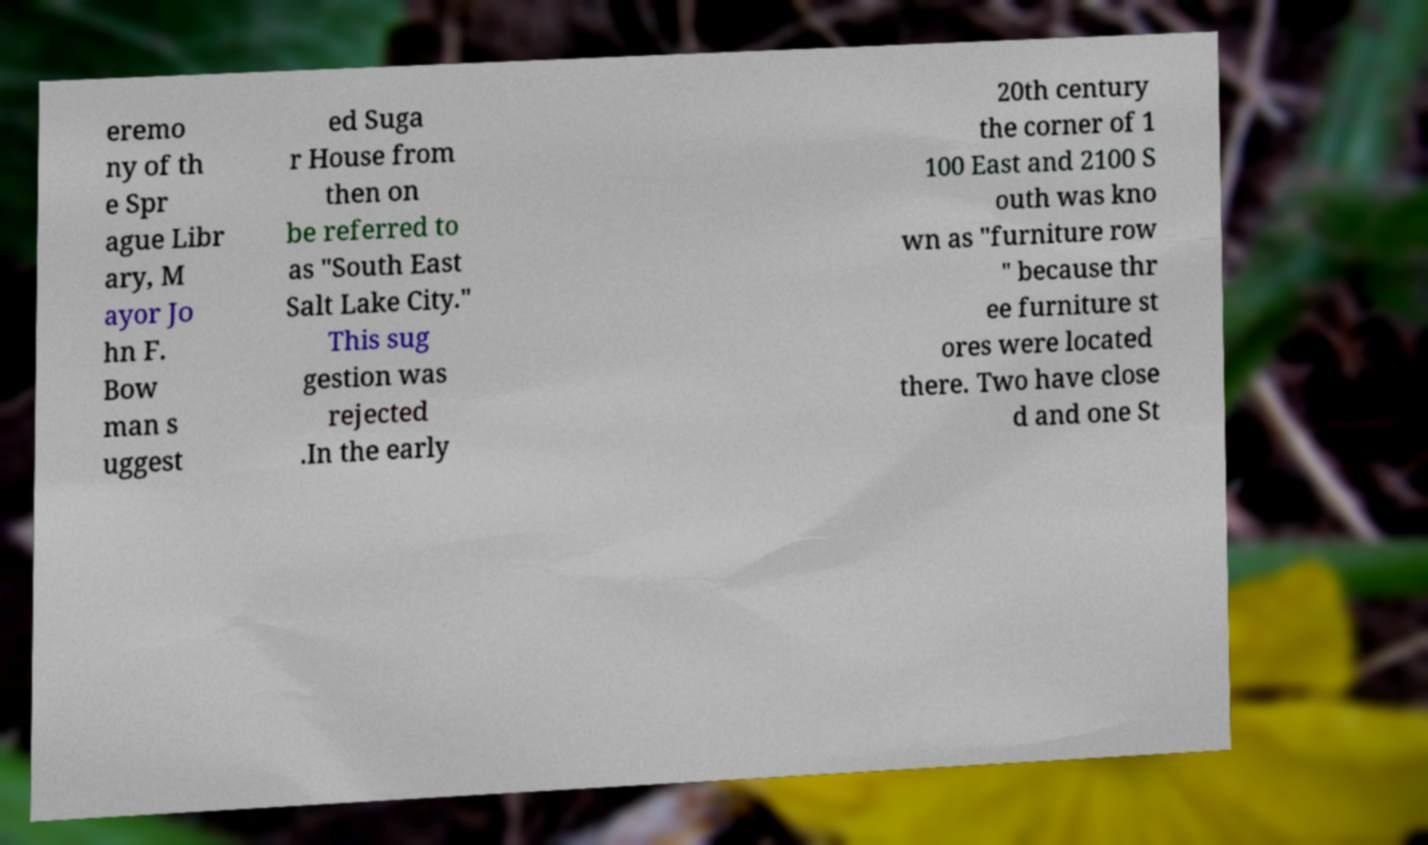Can you read and provide the text displayed in the image?This photo seems to have some interesting text. Can you extract and type it out for me? eremo ny of th e Spr ague Libr ary, M ayor Jo hn F. Bow man s uggest ed Suga r House from then on be referred to as "South East Salt Lake City." This sug gestion was rejected .In the early 20th century the corner of 1 100 East and 2100 S outh was kno wn as "furniture row " because thr ee furniture st ores were located there. Two have close d and one St 